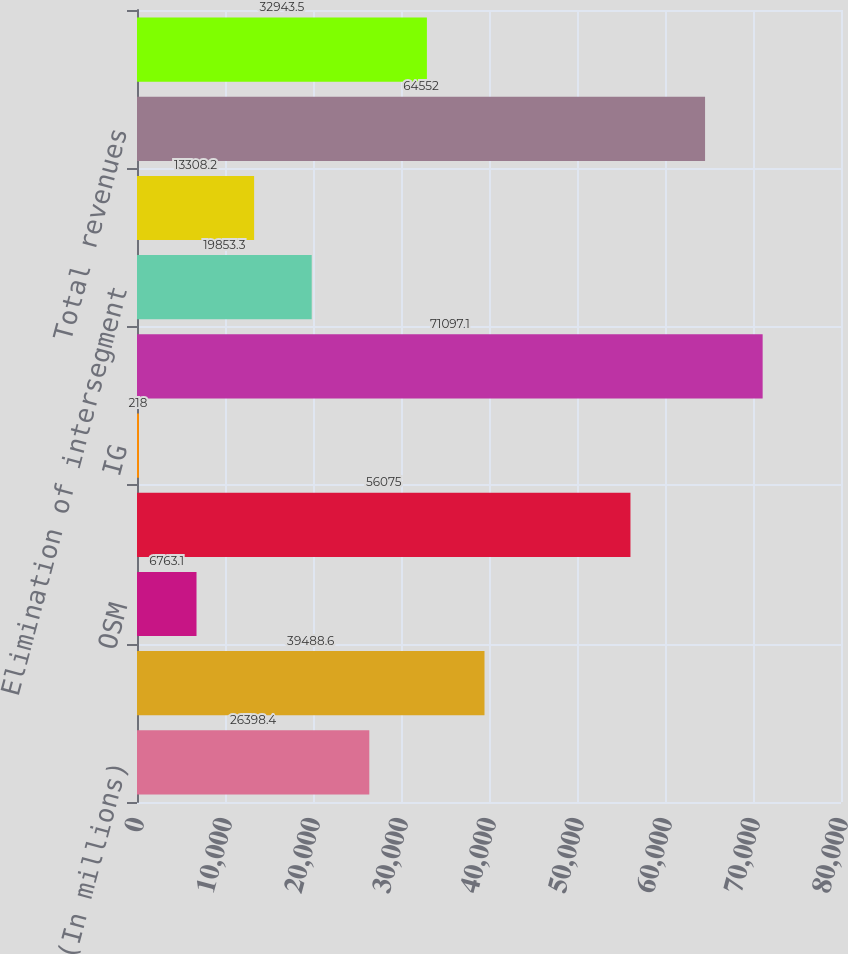Convert chart. <chart><loc_0><loc_0><loc_500><loc_500><bar_chart><fcel>(In millions)<fcel>E&P<fcel>OSM<fcel>RM&T<fcel>IG<fcel>Segment revenues<fcel>Elimination of intersegment<fcel>Gain (loss) on UK gas<fcel>Total revenues<fcel>Consumer excise taxes on<nl><fcel>26398.4<fcel>39488.6<fcel>6763.1<fcel>56075<fcel>218<fcel>71097.1<fcel>19853.3<fcel>13308.2<fcel>64552<fcel>32943.5<nl></chart> 